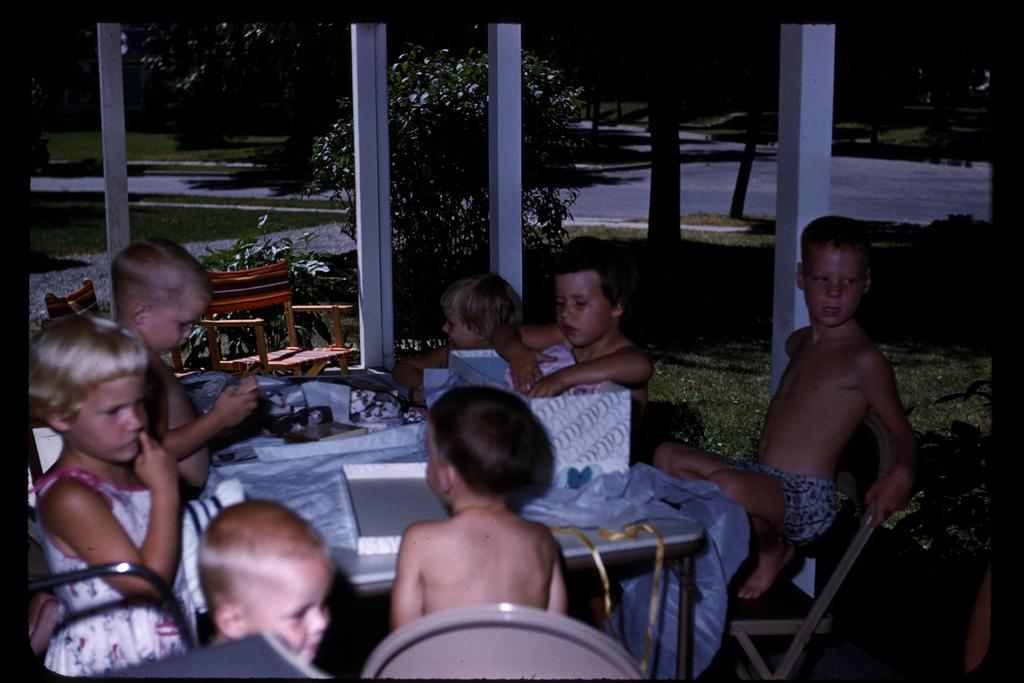Who is present in the image? There are children in the image. What are the children doing in the image? The children are sitting in chairs. Where are the chairs located in relation to the table? The chairs are around a table. What is on the table in the image? There are boxes on the table. What can be seen in the background of the image? There are trees and a road visible in the background of the image. What type of wire is being used for education in the image? There is no wire or reference to education present in the image. 